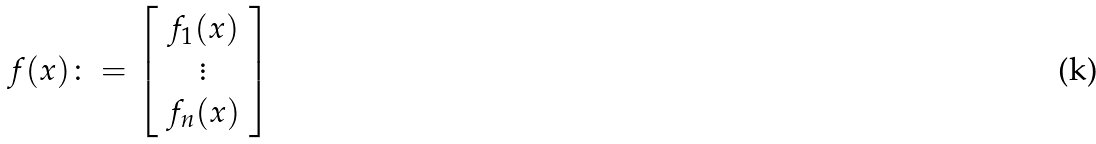Convert formula to latex. <formula><loc_0><loc_0><loc_500><loc_500>f ( x ) \colon = \left [ \begin{array} { c } f _ { 1 } ( x ) \\ \vdots \\ f _ { n } ( x ) \end{array} \right ]</formula> 